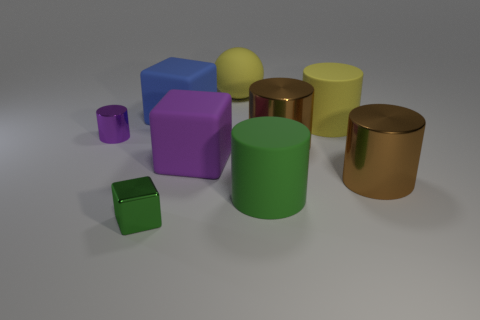What colors are used in this composition? The image showcases a variety of colors. There's a green cube and sphere, a yellow cylinder and sphere, a violet cube, a smaller purple cube, and a bronze-colored cylinder. The colors provide a contrast and contribute to a vibrant palette. 